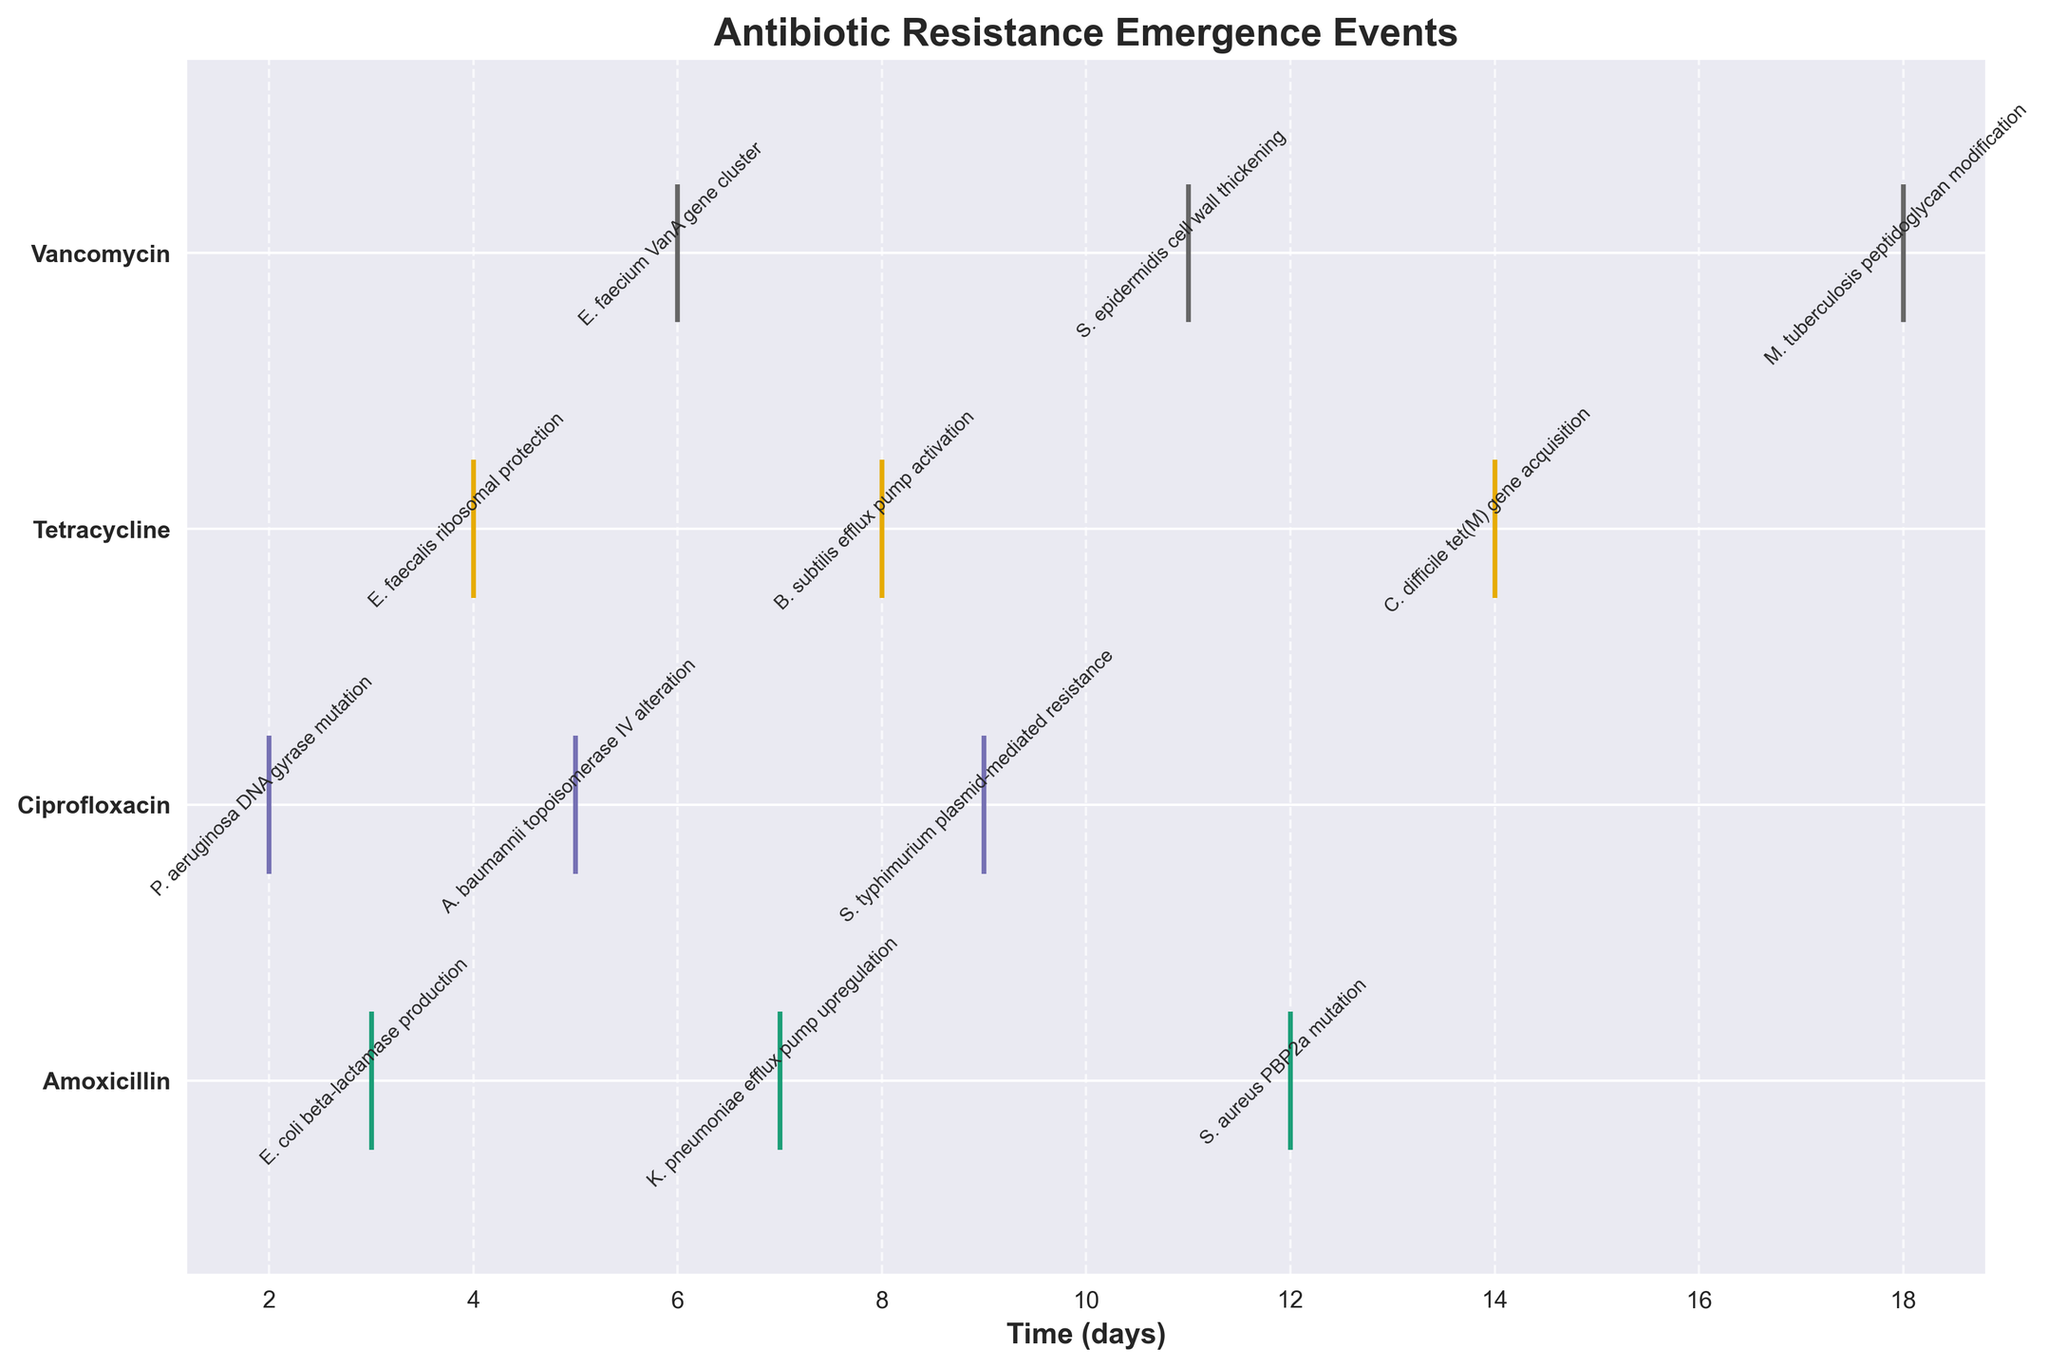How many different treatments are compared in the figure? The figure has distinct horizontal lines for each treatment. Counting the unique line offsets will give us the number of treatments.
Answer: 4 What is the title of the figure? The title is usually found at the top of the figure, describing what the plot is about.
Answer: Antibiotic Resistance Emergence Events Which treatment has the earliest resistance emergence event? By observing the time points along the x-axis for each treatment, the earliest point will be the one closest to the y-axis (0 days).
Answer: Ciprofloxacin Which bacterium exhibited resistance under Amoxicillin at around 7 days? By looking at the data points on the Amoxicillin line around the 7-day mark, we can find the annotated bacterium name.
Answer: K. pneumoniae How many resistance events are annotated under Vancomycin? By counting the number of annotations on the Vancomycin line, we can determine the total events.
Answer: 3 What is the average time in days for resistance emergence under Tetracycline? Sum the time points for Tetracycline and divide by the number of events. (4 + 8 + 14) / 3 = 8.67 days
Answer: 8.67 Which treatment shows the latest resistance emergence event? Find the treatment with the data point farthest to the right on the time axis (x-axis).
Answer: Vancomycin Is there an overlap in resistance emergence times between Ciprofloxacin and Tetracycline? Check if there are any time points that appear on both Ciprofloxacin and Tetracycline's timelines.
Answer: Yes Which bacteria exhibited resistance via efflux pump mechanisms? Identify the annotations mentioning "efflux pump" and note their corresponding treatments.
Answer: K. pneumoniae (Amoxicillin), B. subtilis (Tetracycline) What are the resistance events found in S. aureus and on which days do they occur? Look for "S. aureus" in the annotated events and note the associated time points.
Answer: PBP2a mutation on day 12 